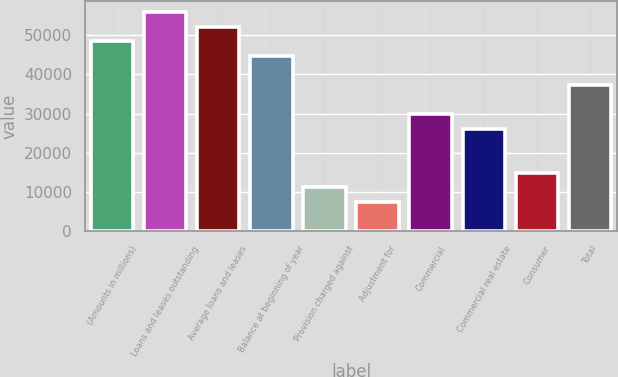Convert chart. <chart><loc_0><loc_0><loc_500><loc_500><bar_chart><fcel>(Amounts in millions)<fcel>Loans and leases outstanding<fcel>Average loans and leases<fcel>Balance at beginning of year<fcel>Provision charged against<fcel>Adjustment for<fcel>Commercial<fcel>Commercial real estate<fcel>Consumer<fcel>Total<nl><fcel>48435.1<fcel>55886.4<fcel>52160.8<fcel>44709.4<fcel>11178.3<fcel>7452.6<fcel>29806.7<fcel>26081<fcel>14904<fcel>37258<nl></chart> 